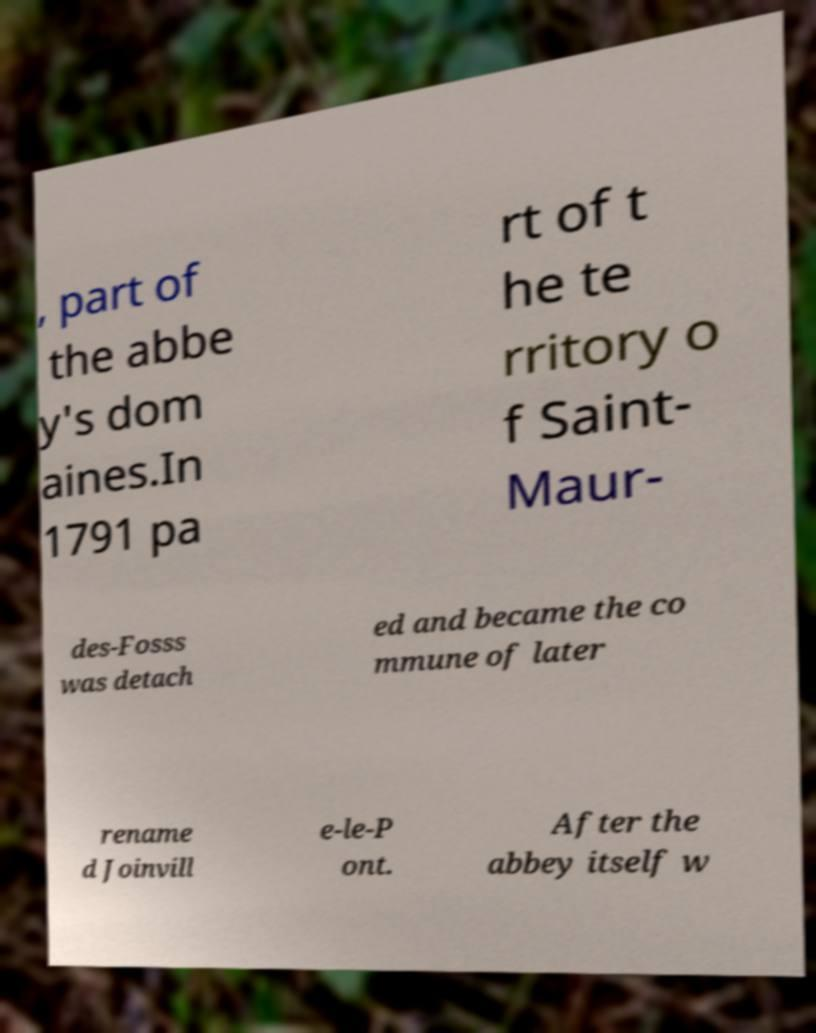There's text embedded in this image that I need extracted. Can you transcribe it verbatim? , part of the abbe y's dom aines.In 1791 pa rt of t he te rritory o f Saint- Maur- des-Fosss was detach ed and became the co mmune of later rename d Joinvill e-le-P ont. After the abbey itself w 